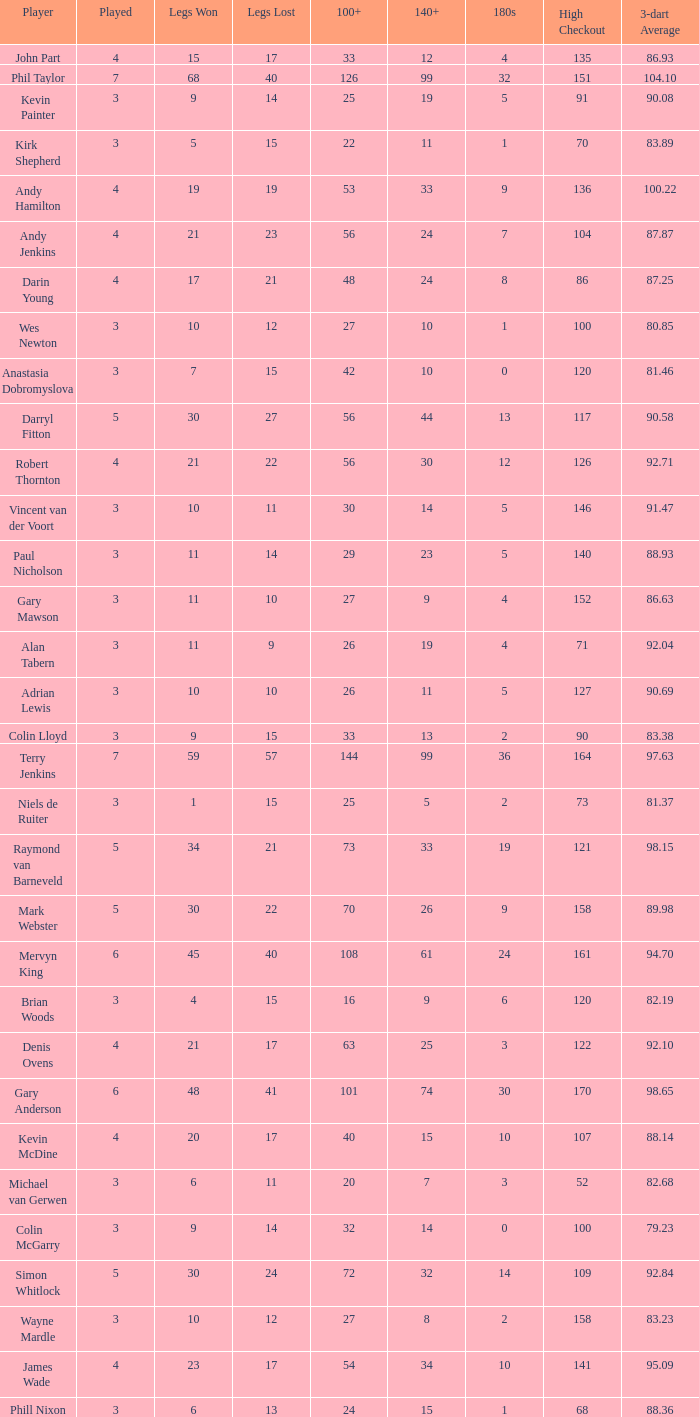What is the lowest high checkout when 140+ is 61, and played is larger than 6? None. Can you parse all the data within this table? {'header': ['Player', 'Played', 'Legs Won', 'Legs Lost', '100+', '140+', '180s', 'High Checkout', '3-dart Average'], 'rows': [['John Part', '4', '15', '17', '33', '12', '4', '135', '86.93'], ['Phil Taylor', '7', '68', '40', '126', '99', '32', '151', '104.10'], ['Kevin Painter', '3', '9', '14', '25', '19', '5', '91', '90.08'], ['Kirk Shepherd', '3', '5', '15', '22', '11', '1', '70', '83.89'], ['Andy Hamilton', '4', '19', '19', '53', '33', '9', '136', '100.22'], ['Andy Jenkins', '4', '21', '23', '56', '24', '7', '104', '87.87'], ['Darin Young', '4', '17', '21', '48', '24', '8', '86', '87.25'], ['Wes Newton', '3', '10', '12', '27', '10', '1', '100', '80.85'], ['Anastasia Dobromyslova', '3', '7', '15', '42', '10', '0', '120', '81.46'], ['Darryl Fitton', '5', '30', '27', '56', '44', '13', '117', '90.58'], ['Robert Thornton', '4', '21', '22', '56', '30', '12', '126', '92.71'], ['Vincent van der Voort', '3', '10', '11', '30', '14', '5', '146', '91.47'], ['Paul Nicholson', '3', '11', '14', '29', '23', '5', '140', '88.93'], ['Gary Mawson', '3', '11', '10', '27', '9', '4', '152', '86.63'], ['Alan Tabern', '3', '11', '9', '26', '19', '4', '71', '92.04'], ['Adrian Lewis', '3', '10', '10', '26', '11', '5', '127', '90.69'], ['Colin Lloyd', '3', '9', '15', '33', '13', '2', '90', '83.38'], ['Terry Jenkins', '7', '59', '57', '144', '99', '36', '164', '97.63'], ['Niels de Ruiter', '3', '1', '15', '25', '5', '2', '73', '81.37'], ['Raymond van Barneveld', '5', '34', '21', '73', '33', '19', '121', '98.15'], ['Mark Webster', '5', '30', '22', '70', '26', '9', '158', '89.98'], ['Mervyn King', '6', '45', '40', '108', '61', '24', '161', '94.70'], ['Brian Woods', '3', '4', '15', '16', '9', '6', '120', '82.19'], ['Denis Ovens', '4', '21', '17', '63', '25', '3', '122', '92.10'], ['Gary Anderson', '6', '48', '41', '101', '74', '30', '170', '98.65'], ['Kevin McDine', '4', '20', '17', '40', '15', '10', '107', '88.14'], ['Michael van Gerwen', '3', '6', '11', '20', '7', '3', '52', '82.68'], ['Colin McGarry', '3', '9', '14', '32', '14', '0', '100', '79.23'], ['Simon Whitlock', '5', '30', '24', '72', '32', '14', '109', '92.84'], ['Wayne Mardle', '3', '10', '12', '27', '8', '2', '158', '83.23'], ['James Wade', '4', '23', '17', '54', '34', '10', '141', '95.09'], ['Phill Nixon', '3', '6', '13', '24', '15', '1', '68', '88.36']]} 